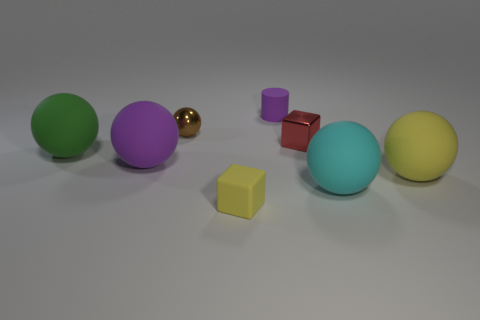There is a tiny object behind the tiny brown thing; what material is it?
Your answer should be very brief. Rubber. What is the size of the cube that is the same material as the large yellow object?
Ensure brevity in your answer.  Small. Do the purple object to the right of the small yellow matte object and the cube that is in front of the green matte thing have the same size?
Make the answer very short. Yes. There is a yellow block that is the same size as the brown thing; what material is it?
Ensure brevity in your answer.  Rubber. The thing that is both in front of the yellow ball and behind the small yellow rubber object is made of what material?
Provide a succinct answer. Rubber. Are there any brown metallic balls?
Make the answer very short. Yes. Do the rubber cylinder and the block that is in front of the large green rubber thing have the same color?
Offer a terse response. No. There is a sphere that is the same color as the rubber block; what is it made of?
Provide a short and direct response. Rubber. Are there any other things that have the same shape as the big cyan matte object?
Your answer should be compact. Yes. There is a tiny matte thing on the left side of the rubber cylinder that is right of the purple matte object left of the brown shiny ball; what shape is it?
Keep it short and to the point. Cube. 